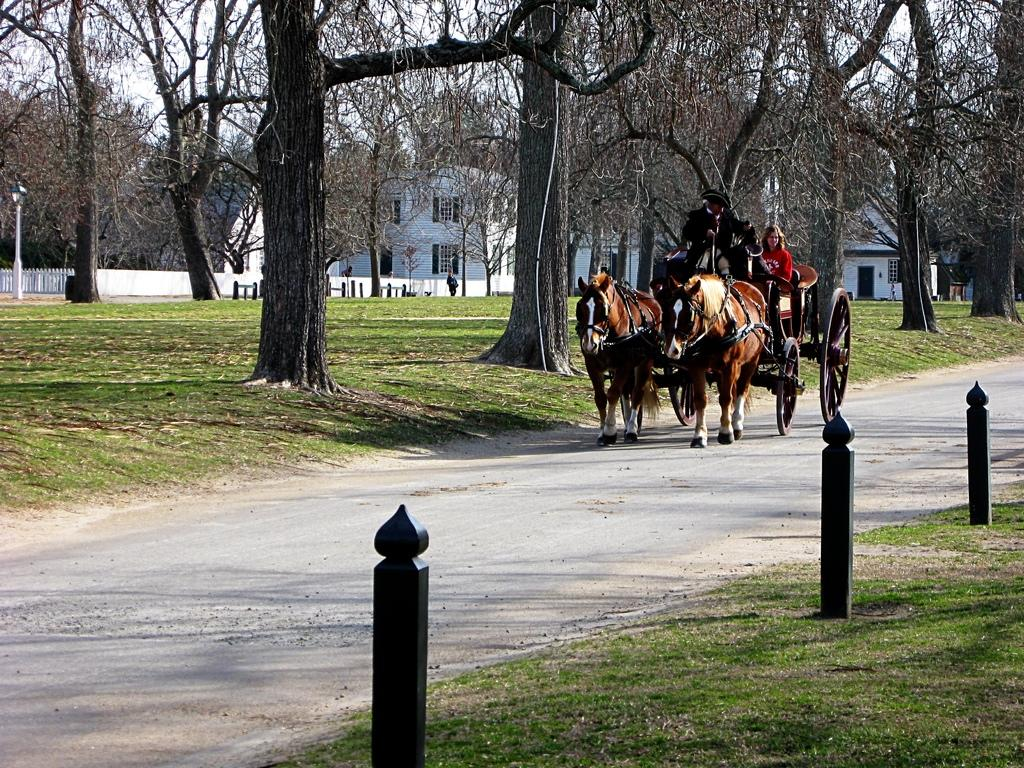What are the persons in the image doing? The persons in the image are sitting in a horse cart. What type of structures can be seen in the image? There are buildings in the image. What type of seating is present in the image? There are benches in the image. What is the cooking apparatus visible in the image? There is a wooden grill in the image. What part of the natural environment is visible in the image? The ground is visible in the image. What type of vegetation is present in the image? There are trees in the image. What type of vertical structures are present in the image? There are poles in the image. What type of pathway is visible in the image? There is a road in the image. What part of the sky is visible in the image? The sky is visible in the image. What type of grape can be seen growing on the poles in the image? There are no grapes present in the image, and the poles are not associated with any vineyard or agricultural activity. What type of waste can be seen on the road in the image? There is no waste visible on the road in the image; the road appears to be clean and clear. 